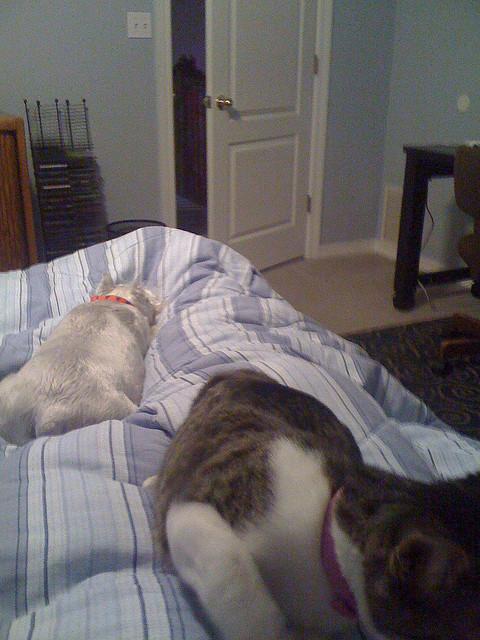Is the cat in the middle of the bed?
Quick response, please. Yes. How many different animals are in the room?
Be succinct. 2. How many beds do the cats have?
Be succinct. 1. What size of bed is this?
Quick response, please. Queen. Are the cats playing?
Keep it brief. No. How many cats are there?
Be succinct. 2. How many cats are on the bed?
Answer briefly. 2. Are the animals on the bed real or toys?
Short answer required. Real. What is the pattern of the comforter?
Keep it brief. Stripes. What color is the floor?
Keep it brief. Tan. 